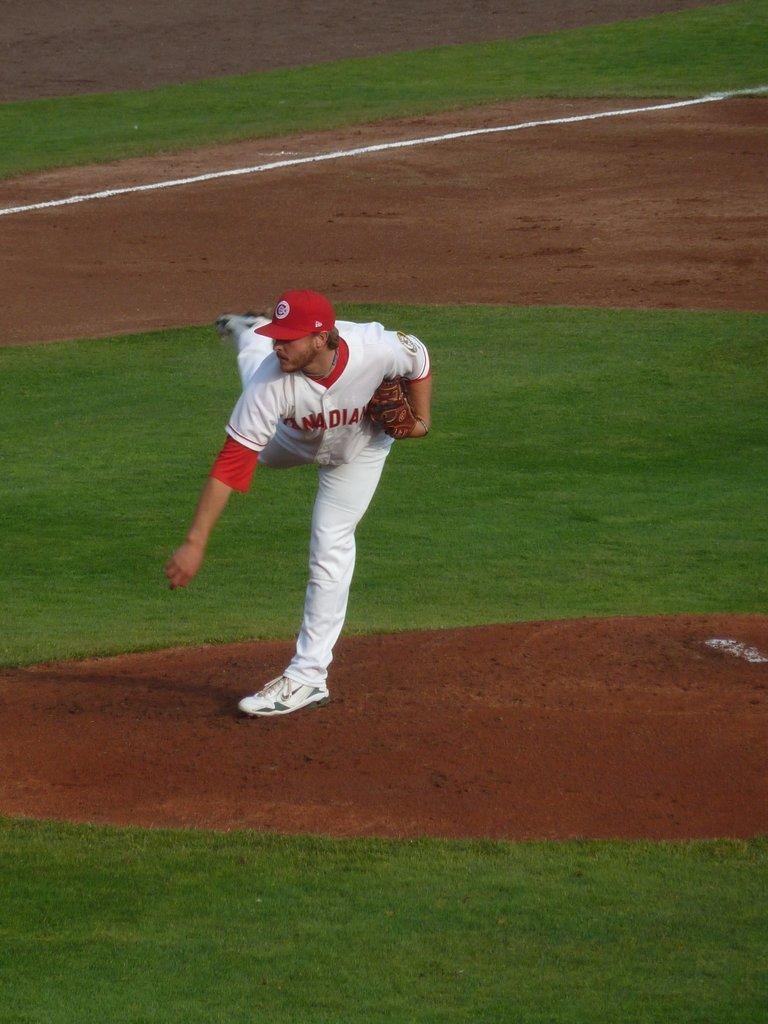<image>
Offer a succinct explanation of the picture presented. a player with the letter C on their hat at a baseball game 